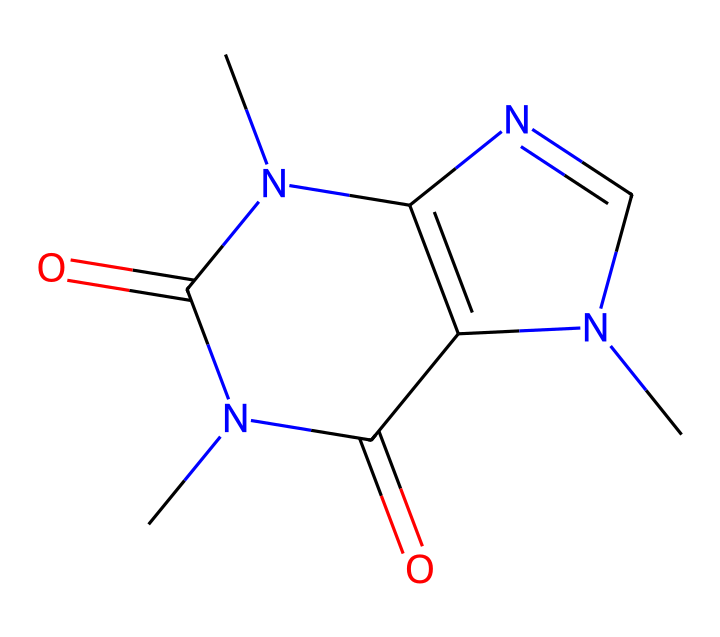What is the molecular formula of this compound? To determine the molecular formula, we first identify the individual atoms in the SMILES representation. Counting the atoms reveals: 8 carbon (C), 10 hydrogen (H), 4 nitrogen (N), and 2 oxygen (O) atoms, leading to the formula C8H10N4O2.
Answer: C8H10N4O2 How many rings are present in the structure? By inspecting the structure, we observe the cyclic formations. The SMILES indicate two interconnected rings in the compound, confirming the presence of two distinct ring structures.
Answer: 2 What type of drug is this chemical? Caffeine is a well-known stimulant that falls under the classification of alkaloids, characterized by its psychoactive properties.
Answer: stimulant What is the role of nitrogen atoms in this chemical? The nitrogen atoms contribute to the basicity of the molecule and are crucial in the pharmacological activity of caffeine, particularly in binding to adenosine receptors in the brain.
Answer: binding How does this chemical primarily exert its stimulating effects? This compound mainly antagonizes adenosine receptors, which prevents the sedative effects of adenosine and leads to increased neuronal excitability, thus stimulating the central nervous system.
Answer: adenosine antagonism What distinguishing feature indicates this is derived from xanthine? The presence of fused rings with specific nitrogen placements and oxygen functionalities resembles the structure of xanthine, a key metabolic precursor for caffeine.
Answer: fused rings How many hydrogen bonds can this chemical likely form? Analyzing the structure, we see potential hydrogen bond donors (like the NH groups) and acceptors (like the carbonyl O). Count shows at least 4 potential hydrogen bonding sites based on the configuration.
Answer: 4 